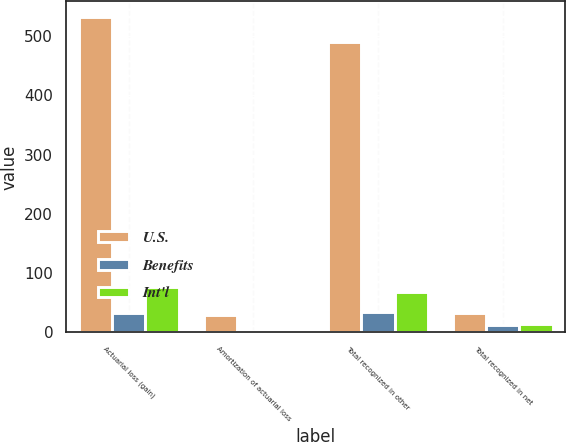Convert chart. <chart><loc_0><loc_0><loc_500><loc_500><stacked_bar_chart><ecel><fcel>Actuarial loss (gain)<fcel>Amortization of actuarial loss<fcel>Total recognized in other<fcel>Total recognized in net<nl><fcel>U.S.<fcel>532<fcel>29<fcel>490<fcel>32<nl><fcel>Benefits<fcel>32<fcel>3<fcel>34<fcel>13<nl><fcel>Int'l<fcel>76<fcel>1<fcel>69<fcel>14<nl></chart> 